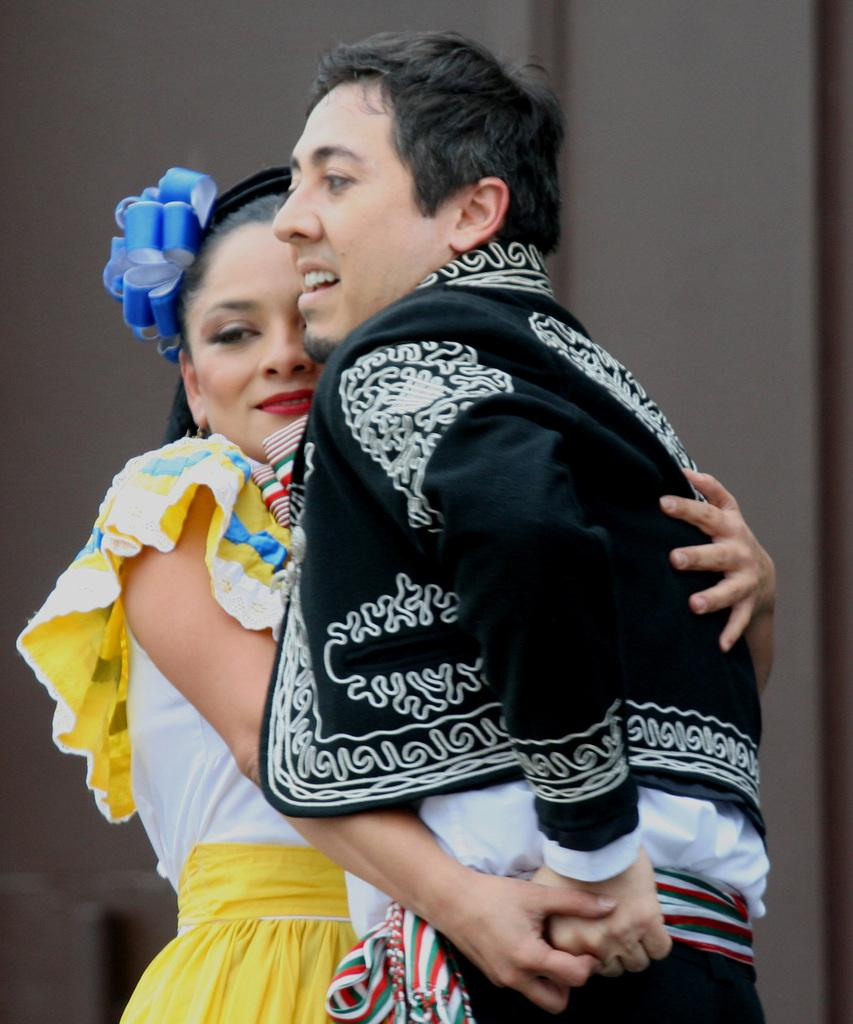How many people are in the image? There are two persons in the foreground of the image. What are the two persons doing in the image? The two persons are standing and hugging each other. What can be seen in the background of the image? There is a wall visible in the background of the image. What type of zebra apparel is the person on the left wearing in the image? There is no zebra apparel present in the image. Can you describe the shoes the persons are wearing in the image? The provided facts do not mention shoes, so we cannot describe them. 